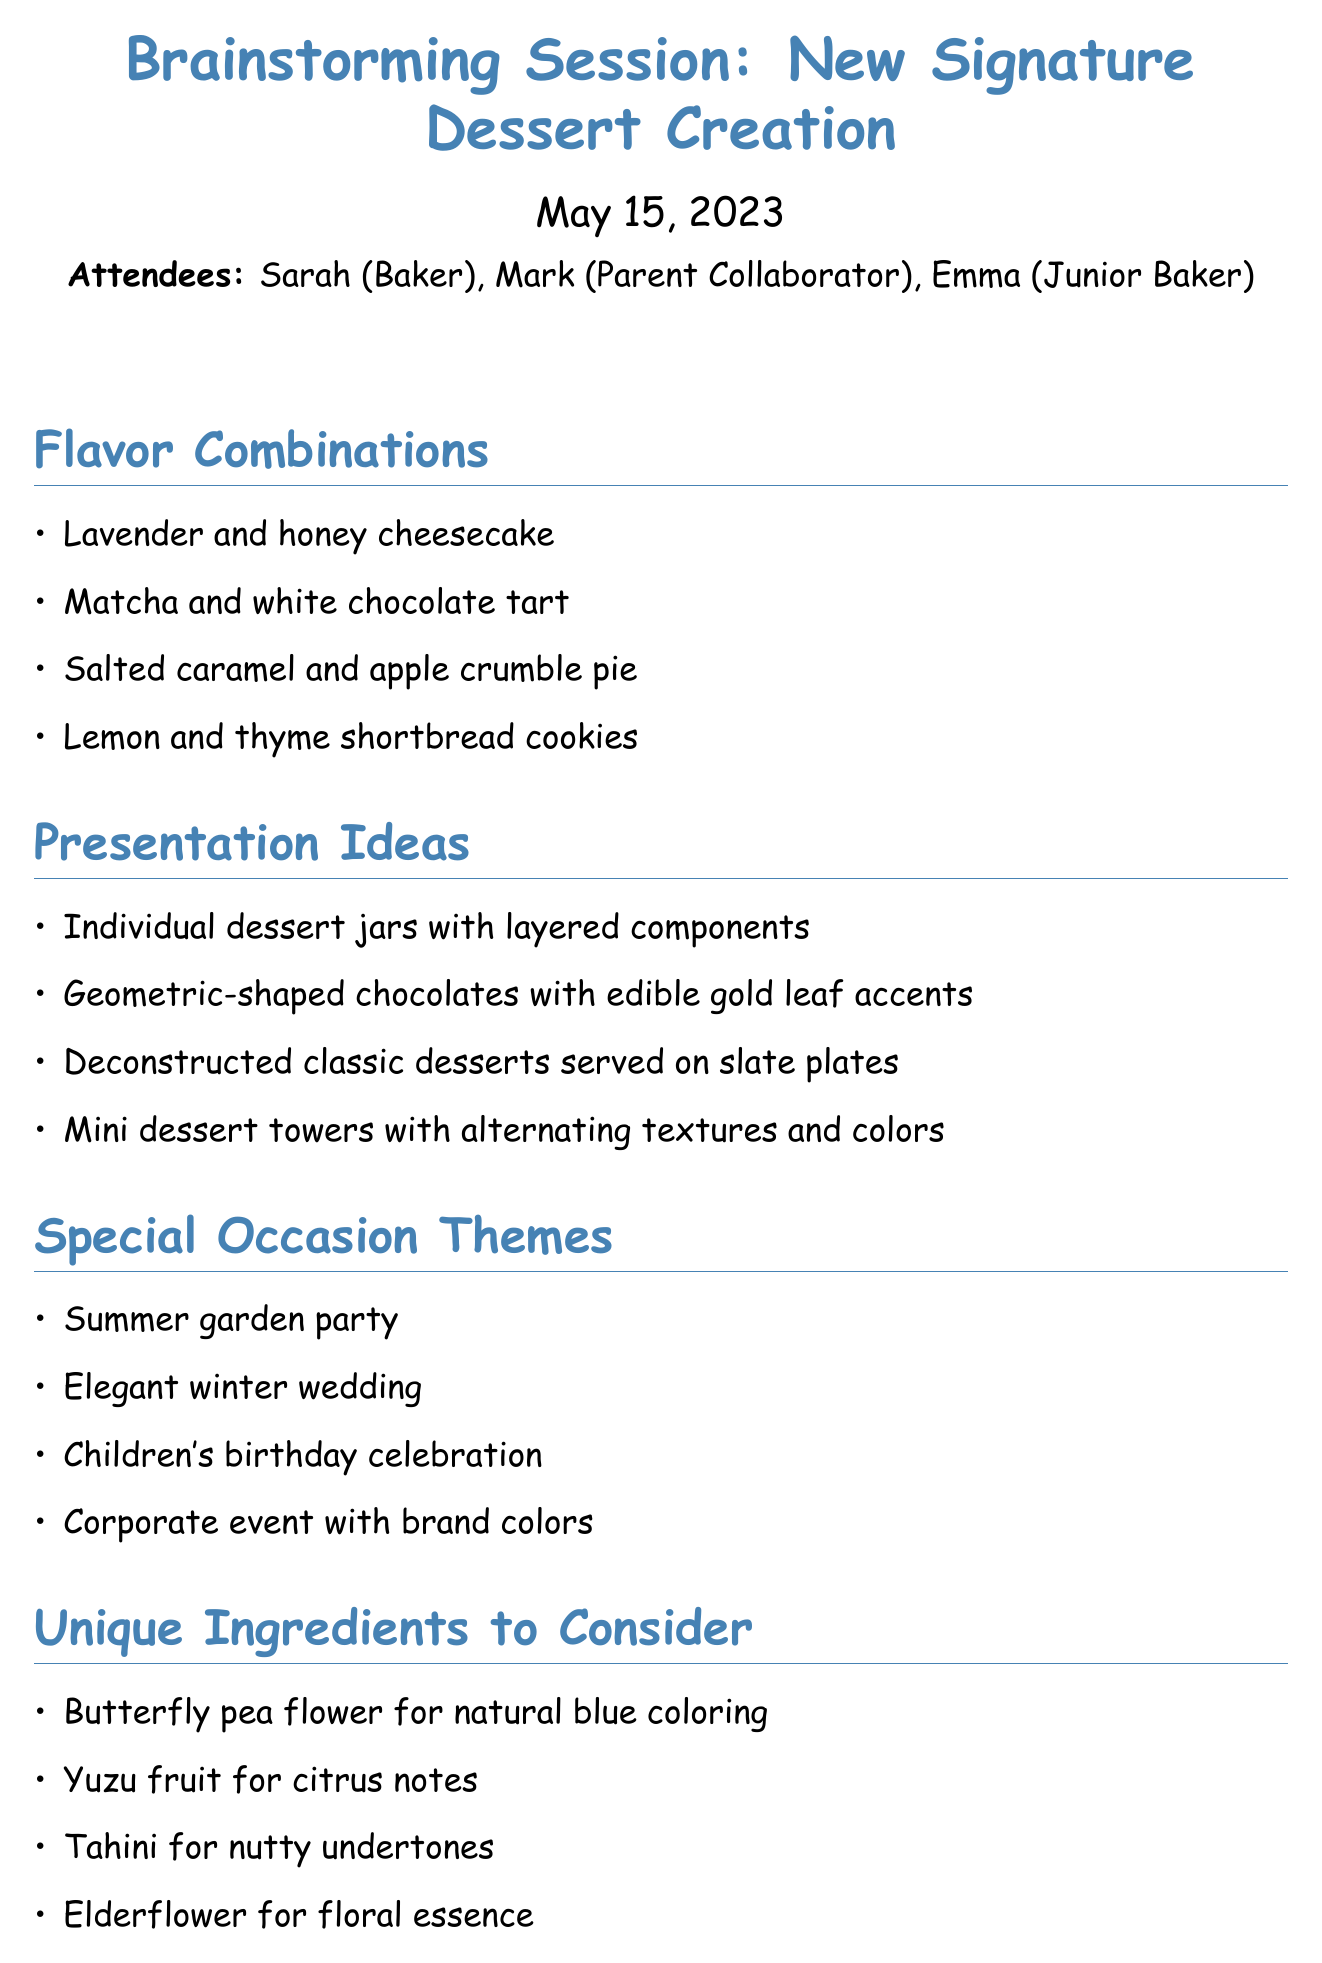what is the date of the meeting? The date of the meeting is listed at the top of the document under the meeting title.
Answer: May 15, 2023 who is one of the attendees? Attendees are listed in the introduction section of the document; one of them can be found there.
Answer: Sarah what is one flavor combination discussed? The flavor combinations are listed in a section; selecting any one from that list would answer this question.
Answer: Lavender and honey cheesecake how many presentation ideas are proposed? The presentation ideas section contains a list; counting those items gives the total number proposed.
Answer: Four what specific ingredient is mentioned for natural blue coloring? The unique ingredients section contains descriptors for each ingredient; identifying the one for blue coloring answers this.
Answer: Butterfly pea flower which special occasion theme suggests a formal setting? The special occasion themes are listed, and identifying one that suggests elegance leads to the answer.
Answer: Elegant winter wedding what is the first action item for next steps? The next steps section lists actions to take; looking at the first item will provide the answer.
Answer: Create prototypes of top 3 flavor combinations how many people attended the meeting? The number of attendees is listed in the introduction section of the document; counting those names gives the total.
Answer: Three 